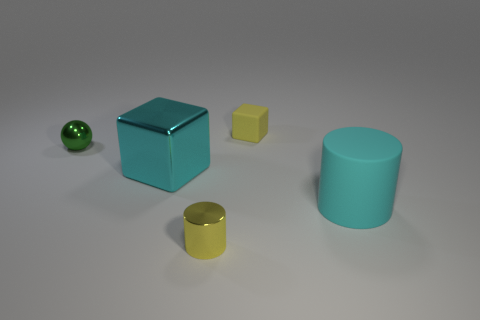Add 1 cyan shiny blocks. How many objects exist? 6 Subtract all cyan cubes. How many cubes are left? 1 Subtract all cylinders. How many objects are left? 3 Subtract all yellow balls. Subtract all gray cylinders. How many balls are left? 1 Subtract all metal cylinders. Subtract all small green metal balls. How many objects are left? 3 Add 1 cyan metal cubes. How many cyan metal cubes are left? 2 Add 5 small brown cylinders. How many small brown cylinders exist? 5 Subtract 0 brown balls. How many objects are left? 5 